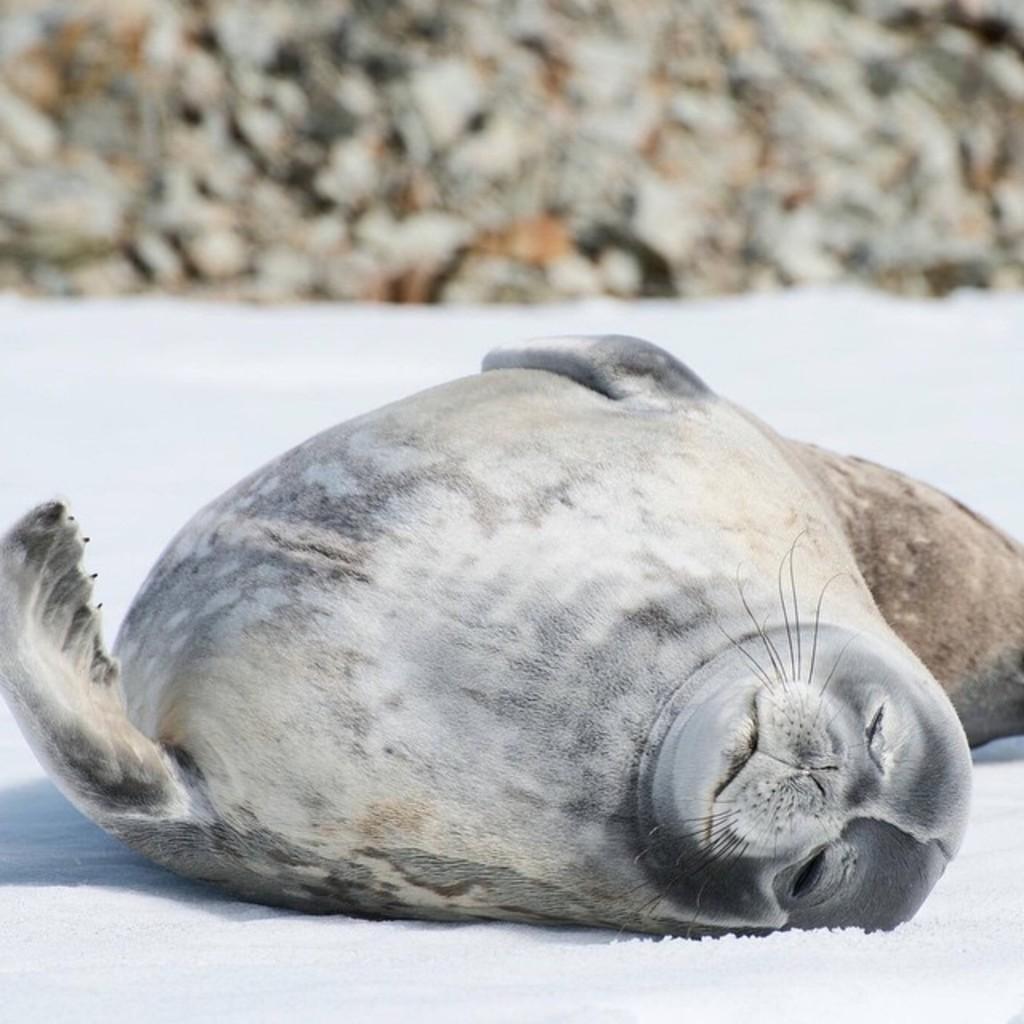What animal is present in the image? There is a black seal in the image. What is the seal doing in the image? The seal is sleeping. What type of ground is the seal resting on? The seal is on the snow ground. How many dogs are visible in the image? There are no dogs present in the image; it features a black seal sleeping on snow ground. What type of clouds can be seen in the image? There is no mention of clouds in the image; it only shows a black seal sleeping on snow ground. 